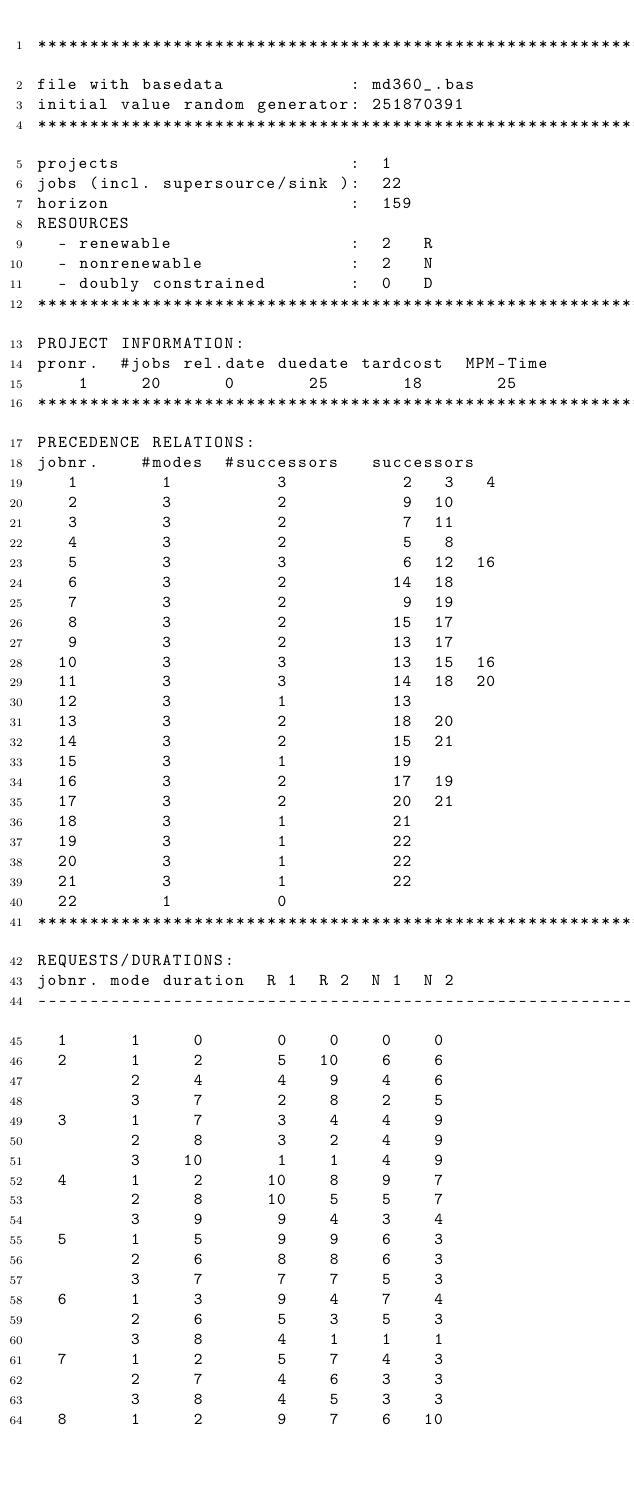<code> <loc_0><loc_0><loc_500><loc_500><_ObjectiveC_>************************************************************************
file with basedata            : md360_.bas
initial value random generator: 251870391
************************************************************************
projects                      :  1
jobs (incl. supersource/sink ):  22
horizon                       :  159
RESOURCES
  - renewable                 :  2   R
  - nonrenewable              :  2   N
  - doubly constrained        :  0   D
************************************************************************
PROJECT INFORMATION:
pronr.  #jobs rel.date duedate tardcost  MPM-Time
    1     20      0       25       18       25
************************************************************************
PRECEDENCE RELATIONS:
jobnr.    #modes  #successors   successors
   1        1          3           2   3   4
   2        3          2           9  10
   3        3          2           7  11
   4        3          2           5   8
   5        3          3           6  12  16
   6        3          2          14  18
   7        3          2           9  19
   8        3          2          15  17
   9        3          2          13  17
  10        3          3          13  15  16
  11        3          3          14  18  20
  12        3          1          13
  13        3          2          18  20
  14        3          2          15  21
  15        3          1          19
  16        3          2          17  19
  17        3          2          20  21
  18        3          1          21
  19        3          1          22
  20        3          1          22
  21        3          1          22
  22        1          0        
************************************************************************
REQUESTS/DURATIONS:
jobnr. mode duration  R 1  R 2  N 1  N 2
------------------------------------------------------------------------
  1      1     0       0    0    0    0
  2      1     2       5   10    6    6
         2     4       4    9    4    6
         3     7       2    8    2    5
  3      1     7       3    4    4    9
         2     8       3    2    4    9
         3    10       1    1    4    9
  4      1     2      10    8    9    7
         2     8      10    5    5    7
         3     9       9    4    3    4
  5      1     5       9    9    6    3
         2     6       8    8    6    3
         3     7       7    7    5    3
  6      1     3       9    4    7    4
         2     6       5    3    5    3
         3     8       4    1    1    1
  7      1     2       5    7    4    3
         2     7       4    6    3    3
         3     8       4    5    3    3
  8      1     2       9    7    6   10</code> 